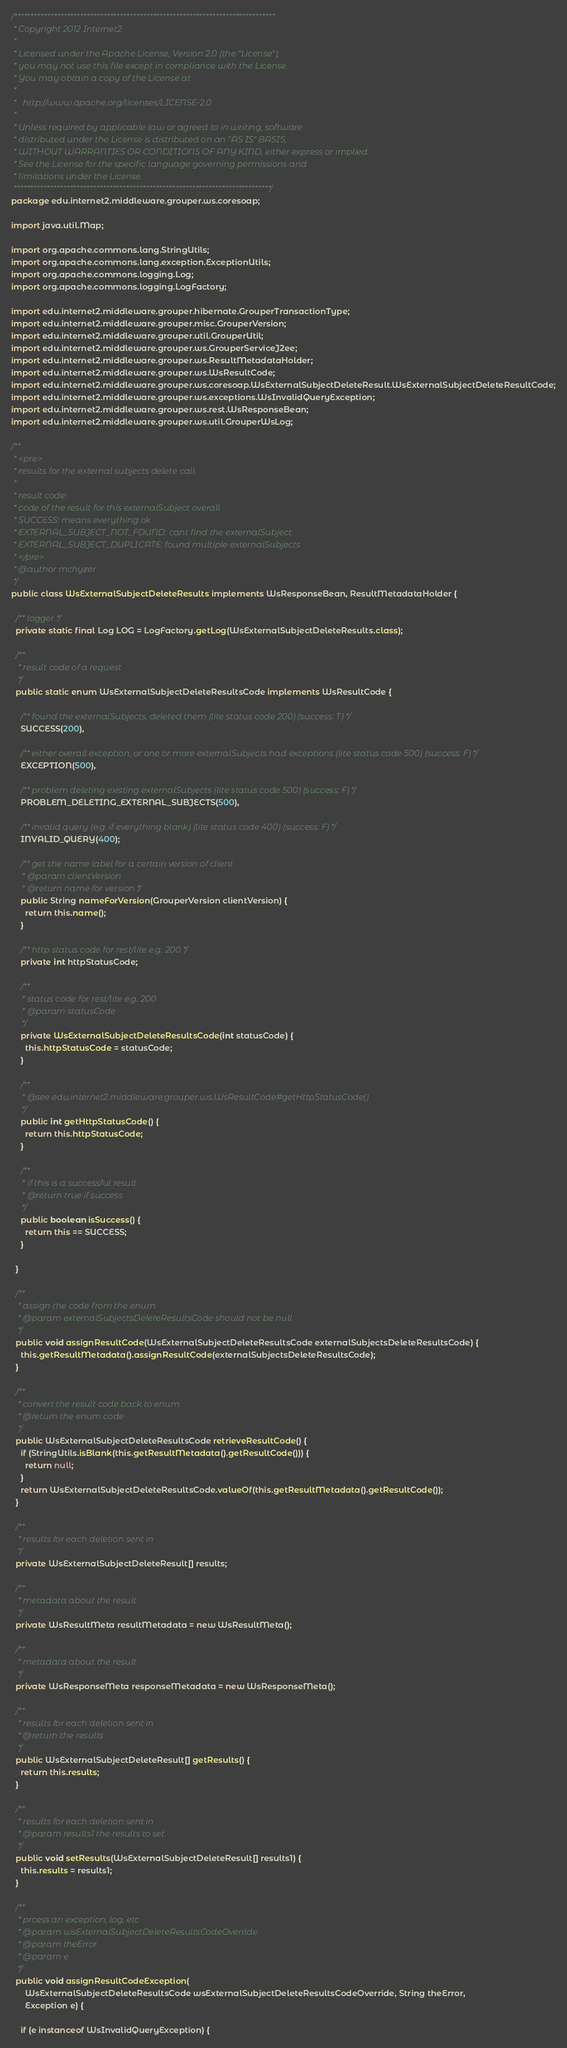Convert code to text. <code><loc_0><loc_0><loc_500><loc_500><_Java_>/*******************************************************************************
 * Copyright 2012 Internet2
 * 
 * Licensed under the Apache License, Version 2.0 (the "License");
 * you may not use this file except in compliance with the License.
 * You may obtain a copy of the License at
 * 
 *   http://www.apache.org/licenses/LICENSE-2.0
 * 
 * Unless required by applicable law or agreed to in writing, software
 * distributed under the License is distributed on an "AS IS" BASIS,
 * WITHOUT WARRANTIES OR CONDITIONS OF ANY KIND, either express or implied.
 * See the License for the specific language governing permissions and
 * limitations under the License.
 ******************************************************************************/
package edu.internet2.middleware.grouper.ws.coresoap;

import java.util.Map;

import org.apache.commons.lang.StringUtils;
import org.apache.commons.lang.exception.ExceptionUtils;
import org.apache.commons.logging.Log;
import org.apache.commons.logging.LogFactory;

import edu.internet2.middleware.grouper.hibernate.GrouperTransactionType;
import edu.internet2.middleware.grouper.misc.GrouperVersion;
import edu.internet2.middleware.grouper.util.GrouperUtil;
import edu.internet2.middleware.grouper.ws.GrouperServiceJ2ee;
import edu.internet2.middleware.grouper.ws.ResultMetadataHolder;
import edu.internet2.middleware.grouper.ws.WsResultCode;
import edu.internet2.middleware.grouper.ws.coresoap.WsExternalSubjectDeleteResult.WsExternalSubjectDeleteResultCode;
import edu.internet2.middleware.grouper.ws.exceptions.WsInvalidQueryException;
import edu.internet2.middleware.grouper.ws.rest.WsResponseBean;
import edu.internet2.middleware.grouper.ws.util.GrouperWsLog;

/**
 * <pre>
 * results for the external subjects delete call.
 * 
 * result code:
 * code of the result for this externalSubject overall
 * SUCCESS: means everything ok
 * EXTERNAL_SUBJECT_NOT_FOUND: cant find the externalSubject
 * EXTERNAL_SUBJECT_DUPLICATE: found multiple externalSubjects
 * </pre>
 * @author mchyzer
 */
public class WsExternalSubjectDeleteResults implements WsResponseBean, ResultMetadataHolder {

  /** logger */
  private static final Log LOG = LogFactory.getLog(WsExternalSubjectDeleteResults.class);

  /**
   * result code of a request
   */
  public static enum WsExternalSubjectDeleteResultsCode implements WsResultCode {

    /** found the externalSubjects, deleted them (lite status code 200) (success: T) */
    SUCCESS(200),

    /** either overall exception, or one or more externalSubjects had exceptions (lite status code 500) (success: F) */
    EXCEPTION(500),

    /** problem deleting existing externalSubjects (lite status code 500) (success: F) */
    PROBLEM_DELETING_EXTERNAL_SUBJECTS(500),

    /** invalid query (e.g. if everything blank) (lite status code 400) (success: F) */
    INVALID_QUERY(400);

    /** get the name label for a certain version of client 
     * @param clientVersion 
     * @return name for version */
    public String nameForVersion(GrouperVersion clientVersion) {
      return this.name();
    }

    /** http status code for rest/lite e.g. 200 */
    private int httpStatusCode;

    /**
     * status code for rest/lite e.g. 200
     * @param statusCode
     */
    private WsExternalSubjectDeleteResultsCode(int statusCode) {
      this.httpStatusCode = statusCode;
    }

    /**
     * @see edu.internet2.middleware.grouper.ws.WsResultCode#getHttpStatusCode()
     */
    public int getHttpStatusCode() {
      return this.httpStatusCode;
    }

    /**
     * if this is a successful result
     * @return true if success
     */
    public boolean isSuccess() {
      return this == SUCCESS;
    }

  }

  /**
   * assign the code from the enum
   * @param externalSubjectsDeleteResultsCode should not be null
   */
  public void assignResultCode(WsExternalSubjectDeleteResultsCode externalSubjectsDeleteResultsCode) {
    this.getResultMetadata().assignResultCode(externalSubjectsDeleteResultsCode);
  }

  /**
   * convert the result code back to enum
   * @return the enum code
   */
  public WsExternalSubjectDeleteResultsCode retrieveResultCode() {
    if (StringUtils.isBlank(this.getResultMetadata().getResultCode())) {
      return null;
    }
    return WsExternalSubjectDeleteResultsCode.valueOf(this.getResultMetadata().getResultCode());
  }

  /**
   * results for each deletion sent in
   */
  private WsExternalSubjectDeleteResult[] results;

  /**
   * metadata about the result
   */
  private WsResultMeta resultMetadata = new WsResultMeta();

  /**
   * metadata about the result
   */
  private WsResponseMeta responseMetadata = new WsResponseMeta();

  /**
   * results for each deletion sent in
   * @return the results
   */
  public WsExternalSubjectDeleteResult[] getResults() {
    return this.results;
  }

  /**
   * results for each deletion sent in
   * @param results1 the results to set
   */
  public void setResults(WsExternalSubjectDeleteResult[] results1) {
    this.results = results1;
  }

  /**
   * prcess an exception, log, etc
   * @param wsExternalSubjectDeleteResultsCodeOverride
   * @param theError
   * @param e
   */
  public void assignResultCodeException(
      WsExternalSubjectDeleteResultsCode wsExternalSubjectDeleteResultsCodeOverride, String theError,
      Exception e) {

    if (e instanceof WsInvalidQueryException) {</code> 